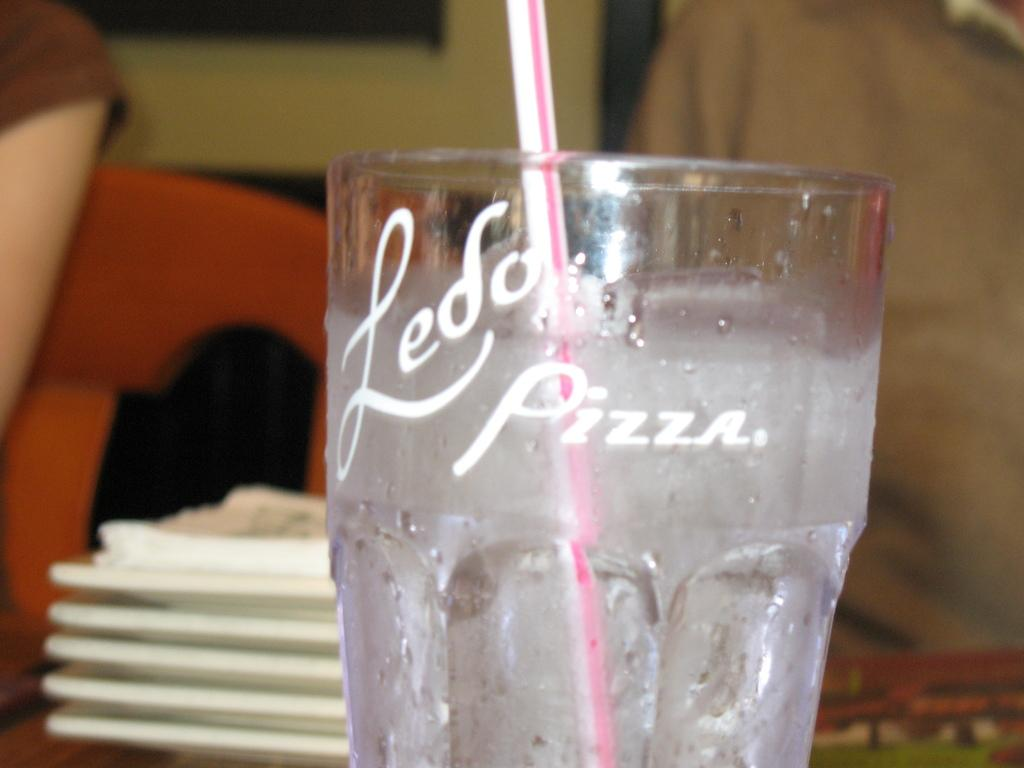<image>
Create a compact narrative representing the image presented. A glass with clear liquid in it reads "Ledo Pizza." 